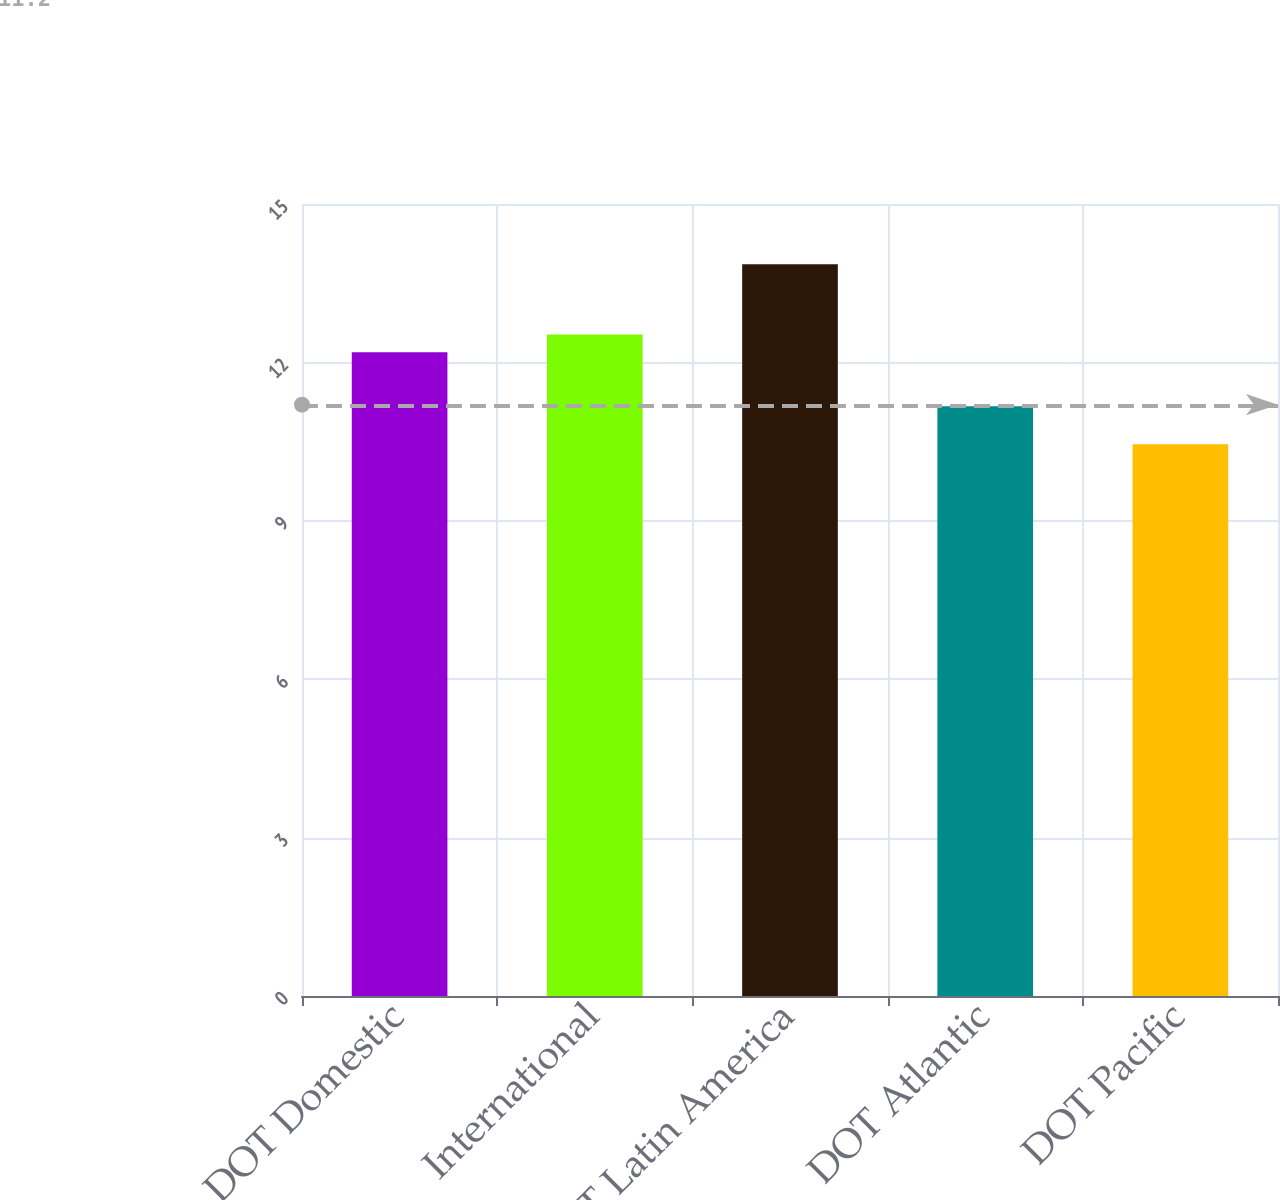Convert chart. <chart><loc_0><loc_0><loc_500><loc_500><bar_chart><fcel>DOT Domestic<fcel>International<fcel>DOT Latin America<fcel>DOT Atlantic<fcel>DOT Pacific<nl><fcel>12.19<fcel>12.53<fcel>13.86<fcel>11.17<fcel>10.45<nl></chart> 